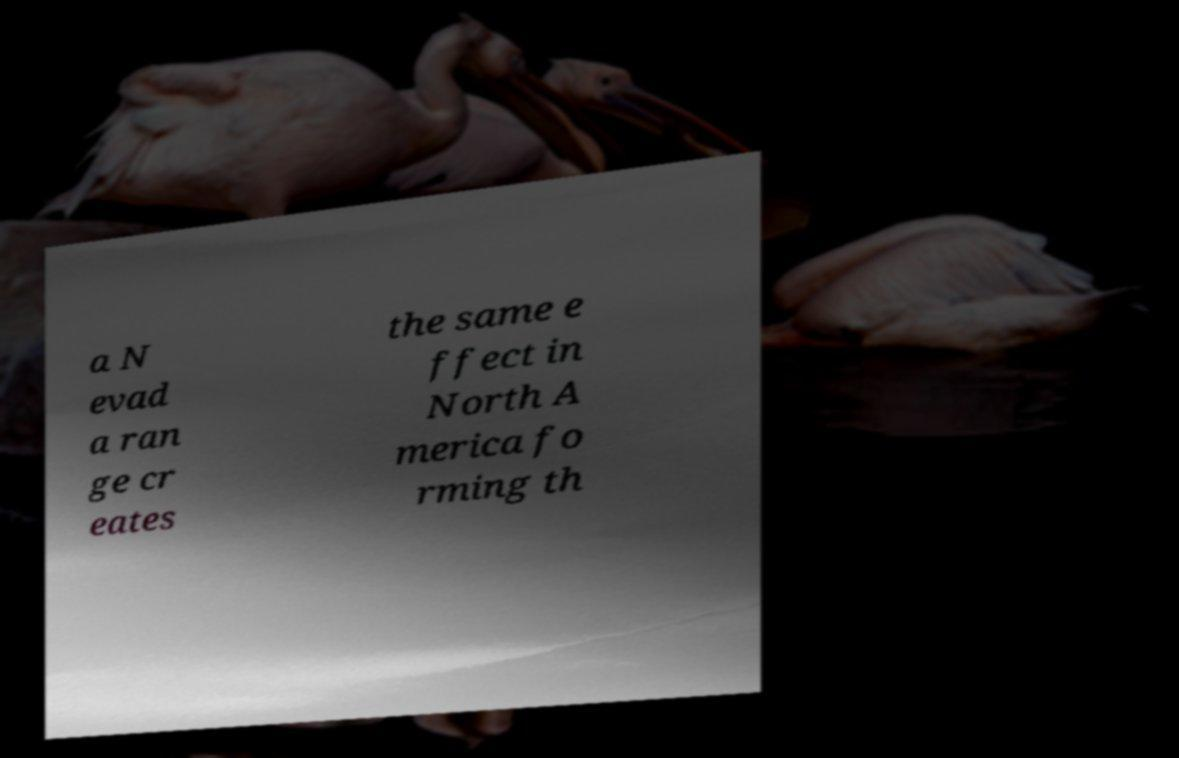Could you extract and type out the text from this image? a N evad a ran ge cr eates the same e ffect in North A merica fo rming th 